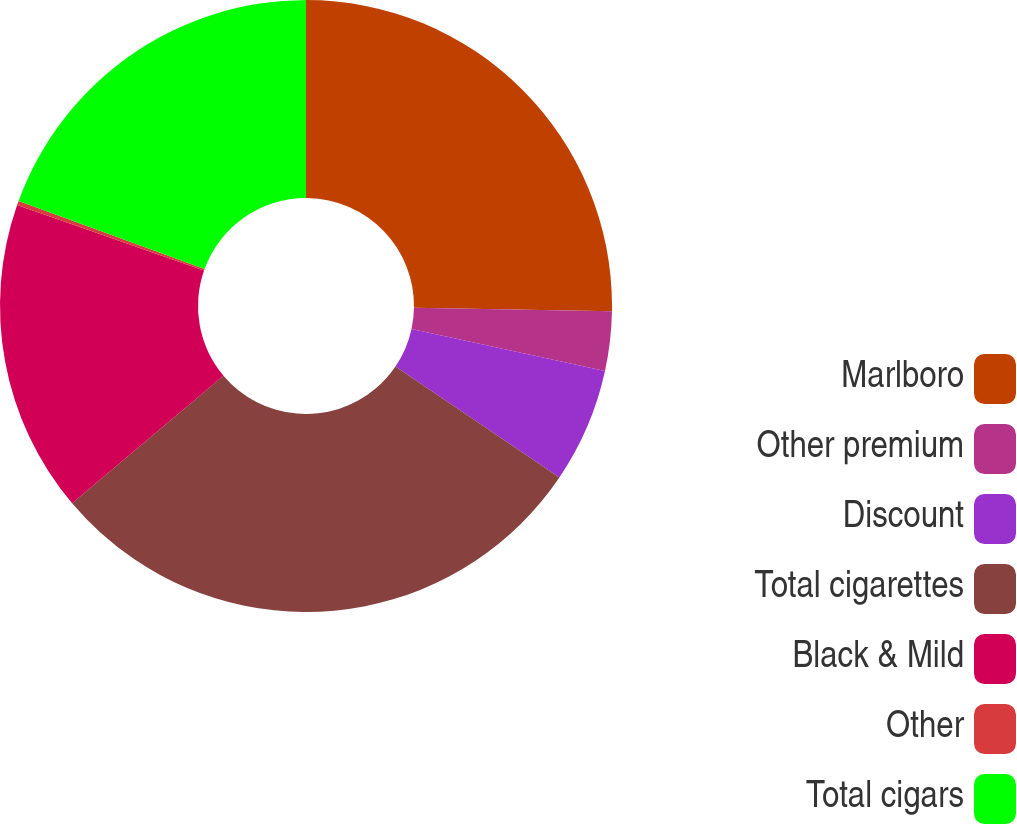Convert chart to OTSL. <chart><loc_0><loc_0><loc_500><loc_500><pie_chart><fcel>Marlboro<fcel>Other premium<fcel>Discount<fcel>Total cigarettes<fcel>Black & Mild<fcel>Other<fcel>Total cigars<nl><fcel>25.27%<fcel>3.14%<fcel>6.06%<fcel>29.37%<fcel>16.5%<fcel>0.23%<fcel>19.42%<nl></chart> 